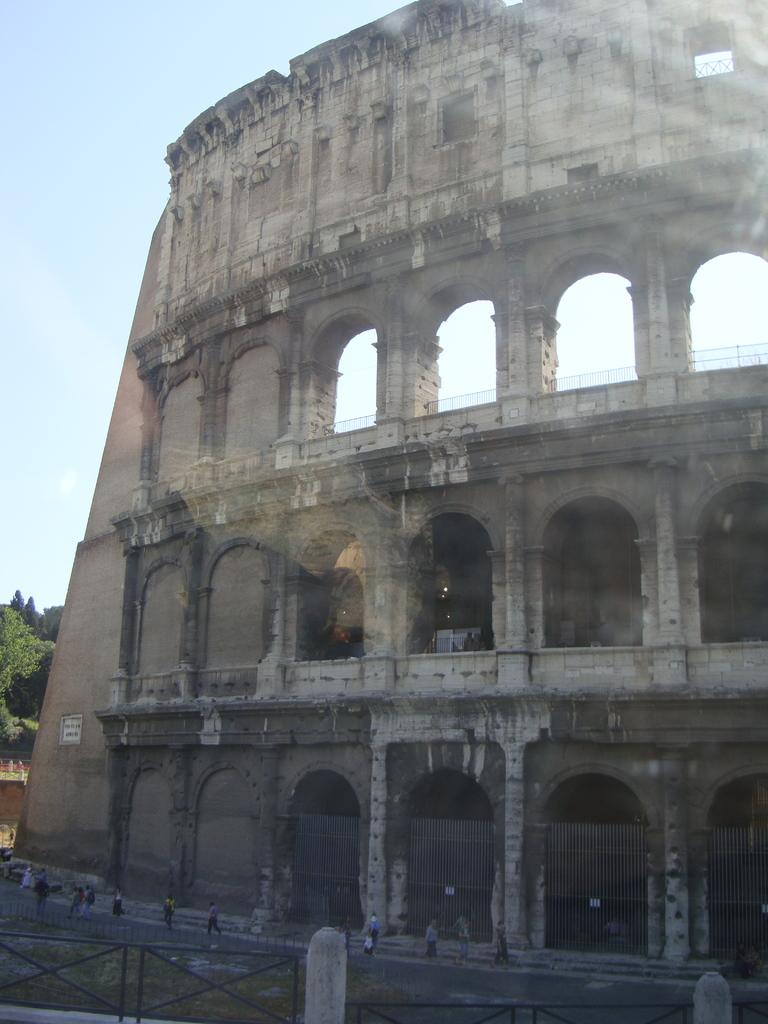What type of structure is depicted in the image? There is a building with arches in the image. What architectural features can be seen on the building? The building has pillars. What safety feature is present in the image? There are railings in the image. How many people are in the image? There are many people in the image. What can be seen in the background of the image? The sky is visible in the background of the image. Can you tell me how many yaks are visible in the image? There are no yaks present in the image; it features a building with arches, pillars, railings, and many people. What type of transportation can be seen in the image? There is no transportation, such as trains, visible in the image; it focuses on a building and its surroundings. 